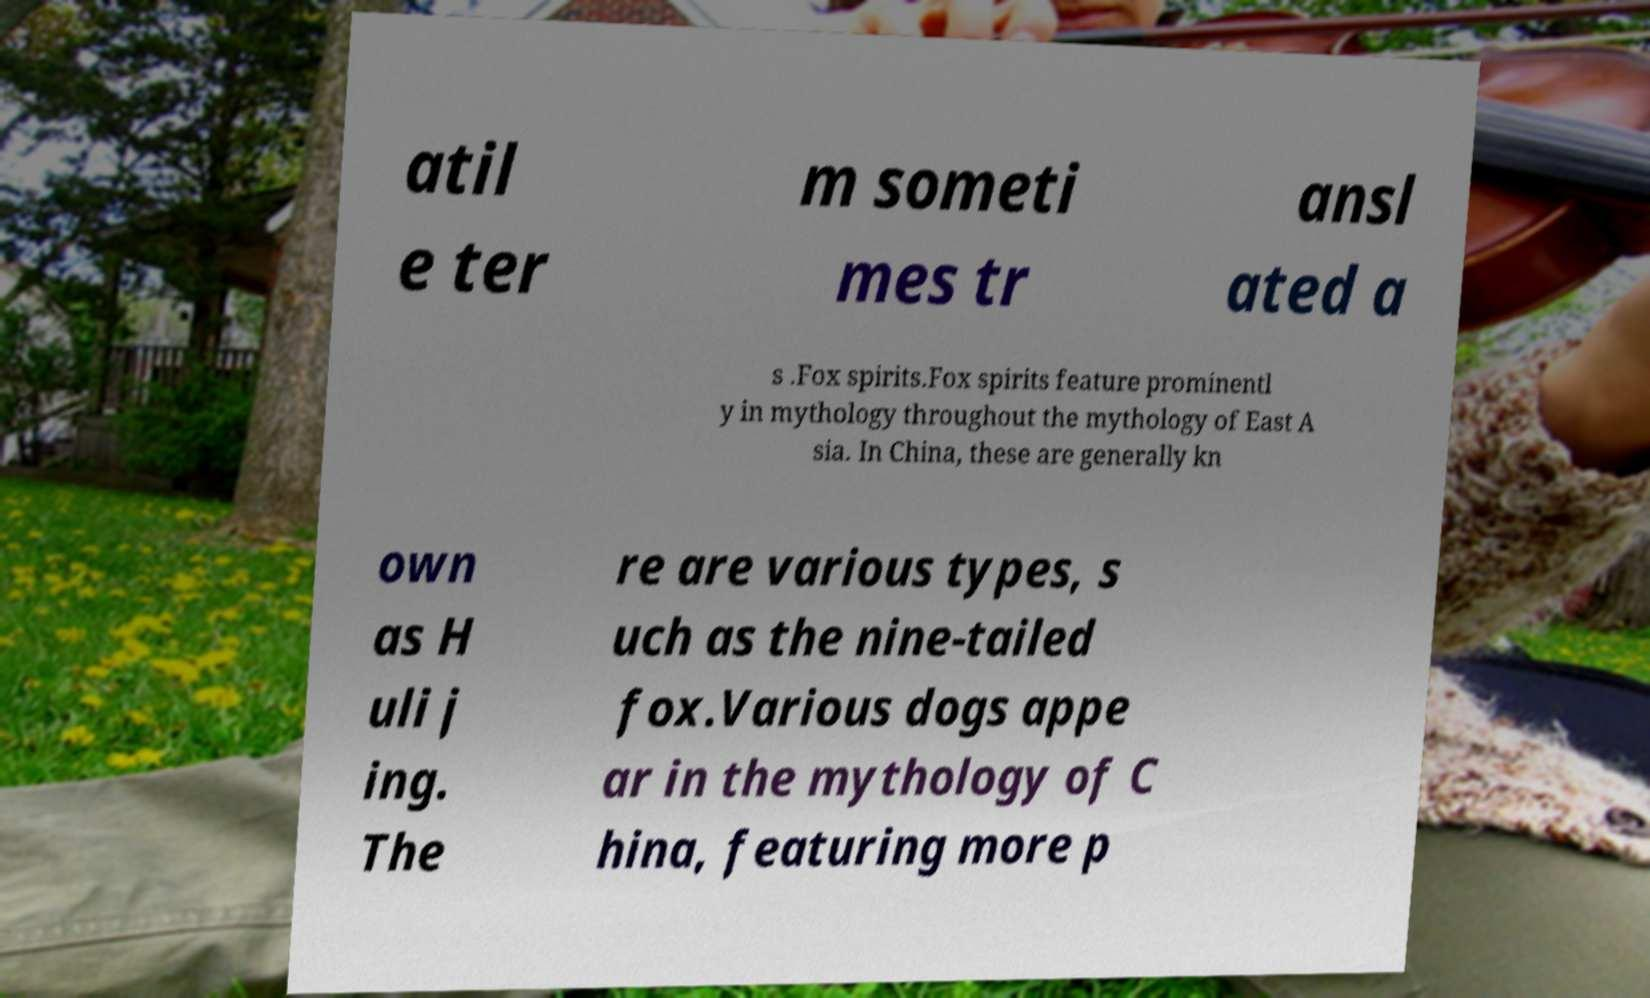Please read and relay the text visible in this image. What does it say? atil e ter m someti mes tr ansl ated a s .Fox spirits.Fox spirits feature prominentl y in mythology throughout the mythology of East A sia. In China, these are generally kn own as H uli j ing. The re are various types, s uch as the nine-tailed fox.Various dogs appe ar in the mythology of C hina, featuring more p 